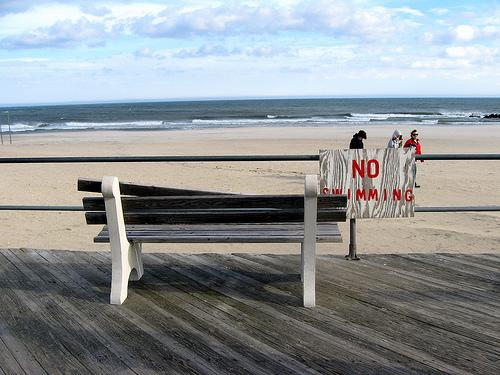Mention the dress code of the people in the image. The people walking on the beach wear diverse clothing, including a red sweater, a gray hoodie, and a black hoodie. Describe the atmosphere of the image using sensory language. A gentle ocean breeze blows as people walk along the sandy beach, taking in the soothing scenery of wooden bench and calming waves. Describe the scene depicted in the image. At a beach location, a group of people is walking along the sand in front of a wooden bench facing the ocean, with a red-lettered sign nearby. Discuss the presence of signs in the image. There is a wooden sign with red lettering near the bench, warning visitors of a no-swimming area. Briefly mention the most prominent objects in the image. A wooden bench, red-lettered sign, ocean, sand, people walking, cloudy sky and broken slat. Describe the overall vibe of the scene in the image. The scene has a relaxed and peaceful atmosphere, as people stroll along the beach and enjoy the view of the ocean and the wooden bench. Write a sentence about the condition of the wooden bench. The wooden bench on the boardwalk is weathered and has a broken slat that has fallen over. Write a sentence about the main focal point in the image. A wooden bench with a missing slat sits on a boardwalk facing the ocean and beach. Mention the primary activity happening in the image. Several people are walking on the beach, enjoying the view of the ocean and wooden bench. Explain the color scheme of the image. The image has a mix of natural colors, with the wooden bench and sign, the blue ocean and sky, the red lettering on the sign, and the gray and black hoodies of the people. 